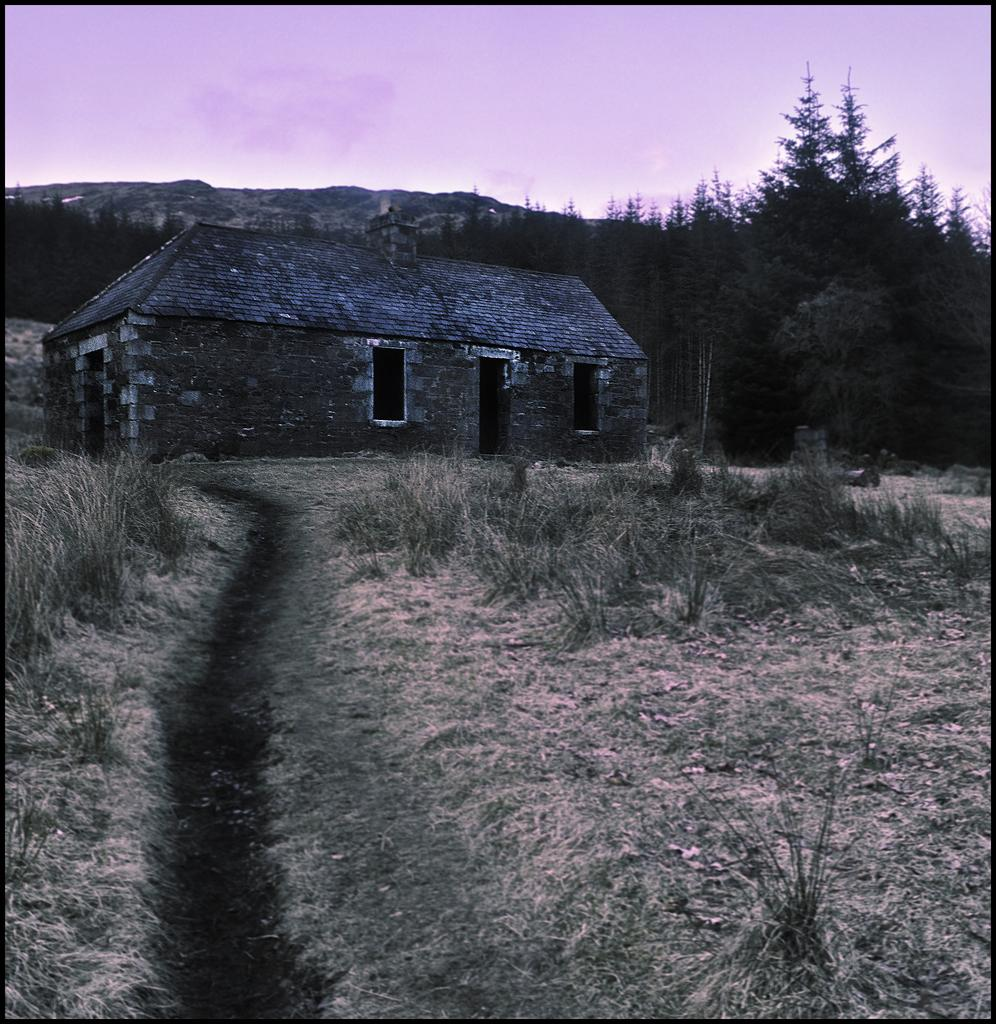What type of surface can be seen in the image? The ground is visible in the image. What type of vegetation is present in the image? There is grass in the image. What feature allows for easy navigation in the image? There is a path in the image. What structures can be seen in the background of the image? There is a house and trees in the background of the image. What natural landmark is visible in the background of the image? There is a mountain in the background of the image. What else can be seen in the sky in the image? The sky is visible in the background of the image. What type of clothing is hanging on the mitten in the image? There is no mitten present in the image, so it is not possible to answer that question. 